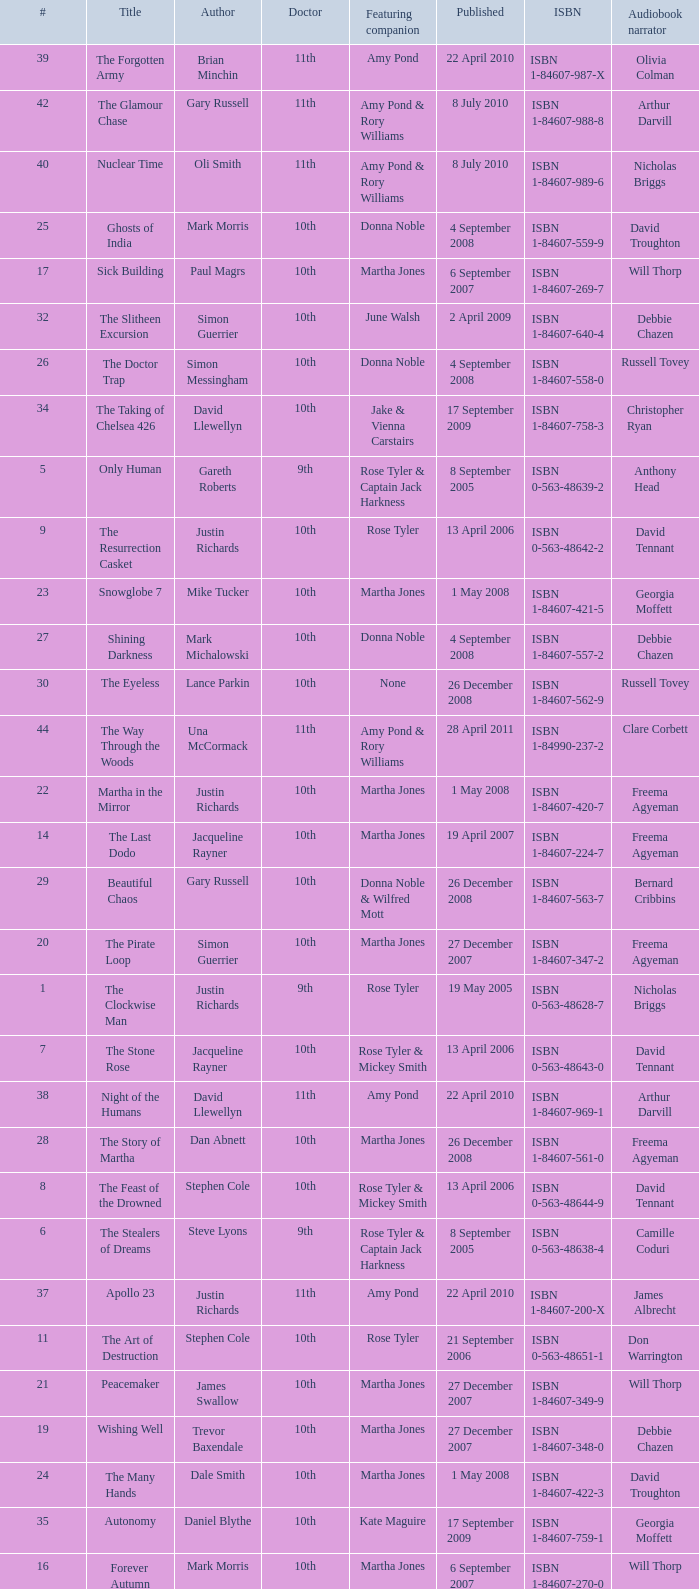Who are the featuring companions of number 3? Rose Tyler & Mickey Smith. Write the full table. {'header': ['#', 'Title', 'Author', 'Doctor', 'Featuring companion', 'Published', 'ISBN', 'Audiobook narrator'], 'rows': [['39', 'The Forgotten Army', 'Brian Minchin', '11th', 'Amy Pond', '22 April 2010', 'ISBN 1-84607-987-X', 'Olivia Colman'], ['42', 'The Glamour Chase', 'Gary Russell', '11th', 'Amy Pond & Rory Williams', '8 July 2010', 'ISBN 1-84607-988-8', 'Arthur Darvill'], ['40', 'Nuclear Time', 'Oli Smith', '11th', 'Amy Pond & Rory Williams', '8 July 2010', 'ISBN 1-84607-989-6', 'Nicholas Briggs'], ['25', 'Ghosts of India', 'Mark Morris', '10th', 'Donna Noble', '4 September 2008', 'ISBN 1-84607-559-9', 'David Troughton'], ['17', 'Sick Building', 'Paul Magrs', '10th', 'Martha Jones', '6 September 2007', 'ISBN 1-84607-269-7', 'Will Thorp'], ['32', 'The Slitheen Excursion', 'Simon Guerrier', '10th', 'June Walsh', '2 April 2009', 'ISBN 1-84607-640-4', 'Debbie Chazen'], ['26', 'The Doctor Trap', 'Simon Messingham', '10th', 'Donna Noble', '4 September 2008', 'ISBN 1-84607-558-0', 'Russell Tovey'], ['34', 'The Taking of Chelsea 426', 'David Llewellyn', '10th', 'Jake & Vienna Carstairs', '17 September 2009', 'ISBN 1-84607-758-3', 'Christopher Ryan'], ['5', 'Only Human', 'Gareth Roberts', '9th', 'Rose Tyler & Captain Jack Harkness', '8 September 2005', 'ISBN 0-563-48639-2', 'Anthony Head'], ['9', 'The Resurrection Casket', 'Justin Richards', '10th', 'Rose Tyler', '13 April 2006', 'ISBN 0-563-48642-2', 'David Tennant'], ['23', 'Snowglobe 7', 'Mike Tucker', '10th', 'Martha Jones', '1 May 2008', 'ISBN 1-84607-421-5', 'Georgia Moffett'], ['27', 'Shining Darkness', 'Mark Michalowski', '10th', 'Donna Noble', '4 September 2008', 'ISBN 1-84607-557-2', 'Debbie Chazen'], ['30', 'The Eyeless', 'Lance Parkin', '10th', 'None', '26 December 2008', 'ISBN 1-84607-562-9', 'Russell Tovey'], ['44', 'The Way Through the Woods', 'Una McCormack', '11th', 'Amy Pond & Rory Williams', '28 April 2011', 'ISBN 1-84990-237-2', 'Clare Corbett'], ['22', 'Martha in the Mirror', 'Justin Richards', '10th', 'Martha Jones', '1 May 2008', 'ISBN 1-84607-420-7', 'Freema Agyeman'], ['14', 'The Last Dodo', 'Jacqueline Rayner', '10th', 'Martha Jones', '19 April 2007', 'ISBN 1-84607-224-7', 'Freema Agyeman'], ['29', 'Beautiful Chaos', 'Gary Russell', '10th', 'Donna Noble & Wilfred Mott', '26 December 2008', 'ISBN 1-84607-563-7', 'Bernard Cribbins'], ['20', 'The Pirate Loop', 'Simon Guerrier', '10th', 'Martha Jones', '27 December 2007', 'ISBN 1-84607-347-2', 'Freema Agyeman'], ['1', 'The Clockwise Man', 'Justin Richards', '9th', 'Rose Tyler', '19 May 2005', 'ISBN 0-563-48628-7', 'Nicholas Briggs'], ['7', 'The Stone Rose', 'Jacqueline Rayner', '10th', 'Rose Tyler & Mickey Smith', '13 April 2006', 'ISBN 0-563-48643-0', 'David Tennant'], ['38', 'Night of the Humans', 'David Llewellyn', '11th', 'Amy Pond', '22 April 2010', 'ISBN 1-84607-969-1', 'Arthur Darvill'], ['28', 'The Story of Martha', 'Dan Abnett', '10th', 'Martha Jones', '26 December 2008', 'ISBN 1-84607-561-0', 'Freema Agyeman'], ['8', 'The Feast of the Drowned', 'Stephen Cole', '10th', 'Rose Tyler & Mickey Smith', '13 April 2006', 'ISBN 0-563-48644-9', 'David Tennant'], ['6', 'The Stealers of Dreams', 'Steve Lyons', '9th', 'Rose Tyler & Captain Jack Harkness', '8 September 2005', 'ISBN 0-563-48638-4', 'Camille Coduri'], ['37', 'Apollo 23', 'Justin Richards', '11th', 'Amy Pond', '22 April 2010', 'ISBN 1-84607-200-X', 'James Albrecht'], ['11', 'The Art of Destruction', 'Stephen Cole', '10th', 'Rose Tyler', '21 September 2006', 'ISBN 0-563-48651-1', 'Don Warrington'], ['21', 'Peacemaker', 'James Swallow', '10th', 'Martha Jones', '27 December 2007', 'ISBN 1-84607-349-9', 'Will Thorp'], ['19', 'Wishing Well', 'Trevor Baxendale', '10th', 'Martha Jones', '27 December 2007', 'ISBN 1-84607-348-0', 'Debbie Chazen'], ['24', 'The Many Hands', 'Dale Smith', '10th', 'Martha Jones', '1 May 2008', 'ISBN 1-84607-422-3', 'David Troughton'], ['35', 'Autonomy', 'Daniel Blythe', '10th', 'Kate Maguire', '17 September 2009', 'ISBN 1-84607-759-1', 'Georgia Moffett'], ['16', 'Forever Autumn', 'Mark Morris', '10th', 'Martha Jones', '6 September 2007', 'ISBN 1-84607-270-0', 'Will Thorp'], ['4', 'The Deviant Strain', 'Justin Richards', '9th', 'Rose Tyler & Captain Jack Harkness', '8 September 2005', 'ISBN 0-563-48637-6', 'Stuart Milligan'], ['48', 'Borrowed Time', 'Naomi Alderman', '11th', 'Amy Pond & Rory Williams', '23 June 2011', 'ISBN 1-84990-233-X', 'Meera Syal'], ['2', 'The Monsters Inside', 'Stephen Cole', '9th', 'Rose Tyler', '19 May 2005', 'ISBN 0-563-48629-5', 'Camille Coduri'], ['10', 'The Nightmare of Black Island', 'Mike Tucker', '10th', 'Rose Tyler', '21 September 2006', 'ISBN 0-563-48650-3', 'Anthony Head'], ['S2', 'The Silent Stars Go By', 'Dan Abnett', '11th', 'Amy Pond & Rory Williams', '29 September 2011', 'ISBN 1-84990-243-7', 'Michael Maloney'], ['31', 'Judgement of the Judoon', 'Colin Brake', '10th', 'Nikki Jupiter', '2 April 2009', 'ISBN 1-84607-639-0', 'Nicholas Briggs'], ['46', 'Touched by an Angel', 'Jonathan Morris', '11th', 'Amy Pond & Rory Williams', '23 June 2011', 'ISBN 1-84990-234-8', 'Clare Corbett'], ['18', 'Wetworld', 'Mark Michalowski', '10th', 'Martha Jones', '6 September 2007', 'ISBN 1-84607-271-9', 'Freema Agyeman'], ['41', "The King's Dragon", 'Una McCormack', '11th', 'Amy Pond & Rory Williams', '8 July 2010', 'ISBN 1-84607-990-X', 'Nicholas Briggs'], ['47', 'Paradox Lost', 'George Mann', '11th', 'Amy Pond & Rory Williams', '23 June 2011', 'ISBN 1-84990-235-6', 'Nicholas Briggs'], ['33', 'Prisoner of the Daleks', 'Trevor Baxendale', '10th', 'Jon Bowman', '2 April 2009', 'ISBN 1-84607-641-2', 'Nicholas Briggs'], ['45', "Hunter's Moon", 'Paul Finch', '11th', 'Amy Pond & Rory Williams', '28 April 2011', 'ISBN 1-84990-236-4', 'Arthur Darvill'], ['13', 'Sting of the Zygons', 'Stephen Cole', '10th', 'Martha Jones', '19 April 2007', 'ISBN 1-84607-225-5', 'Reggie Yates'], ['12', 'The Price of Paradise', 'Colin Brake', '10th', 'Rose Tyler', '21 September 2006', 'ISBN 0-563-48652-X', 'Shaun Dingwall'], ['15', 'Wooden Heart', 'Martin Day', '10th', 'Martha Jones', '19 April 2007', 'ISBN 1-84607-226-3', 'Adjoa Andoh'], ['43', 'Dead of Winter', 'James Goss', '11th', 'Amy Pond & Rory Williams', '28 April 2011', 'ISBN 1-84990-238-0', 'Clare Corbett'], ['S1', 'The Coming of the Terraphiles', 'Michael Moorcock', '11th', 'Amy Pond', '14 October 2010', 'ISBN 1-84607-983-7', 'Clive Mantle'], ['S3', 'Dark Horizons', 'J T Colgan', '11th', 'None', '7 July 2012', 'ISBN 1-84990-456-1', 'Neve McIntosh'], ['36', 'The Krillitane Storm', 'Christopher Cooper', '10th', 'Emily Parr', '17 September 2009', 'ISBN 1-84607-761-3', 'Will Thorp'], ['3', 'Winner Takes All', 'Jacqueline Rayner', '9th', 'Rose Tyler & Mickey Smith', '19 May 2005', 'ISBN 0-563-48627-9', 'Camille Coduri']]} 